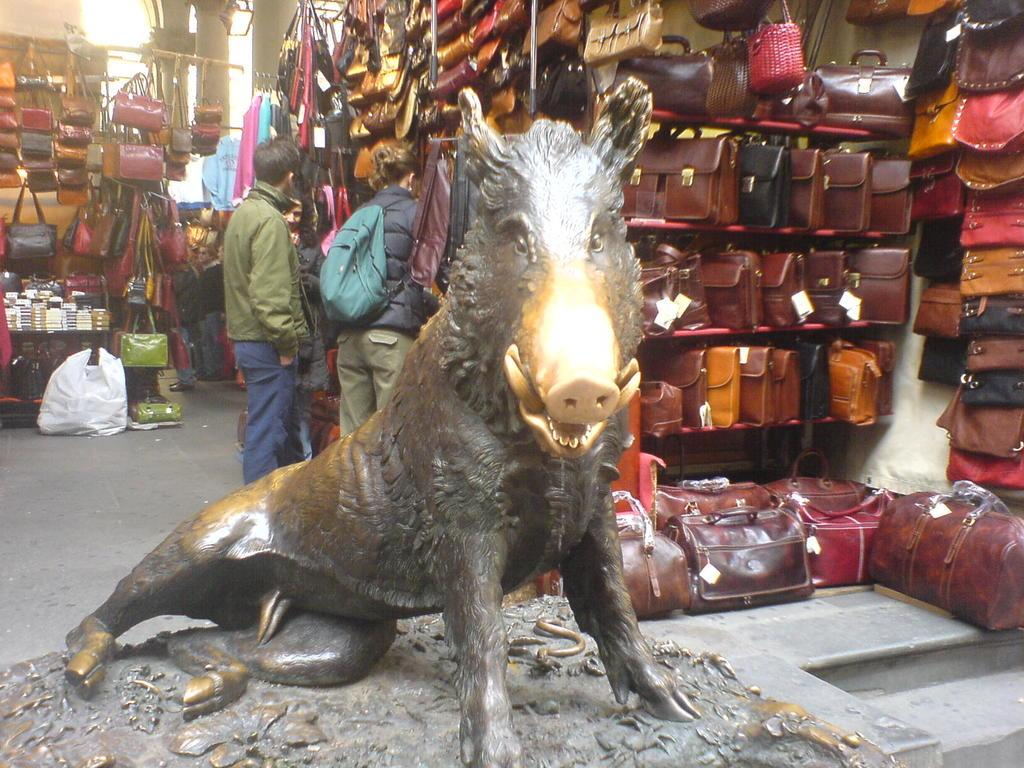What is the main subject of the image? There is a statue of an animal in the image. What can be seen in the background of the image? There are bags placed on a rack in the background. How many people are present in the image? There are three people standing at the backside of the statue. What type of basketball game is being played in the image? There is no basketball game present in the image; it features a statue of an animal and people standing nearby. Can you describe the veins visible in the image? There are no veins visible in the image. 